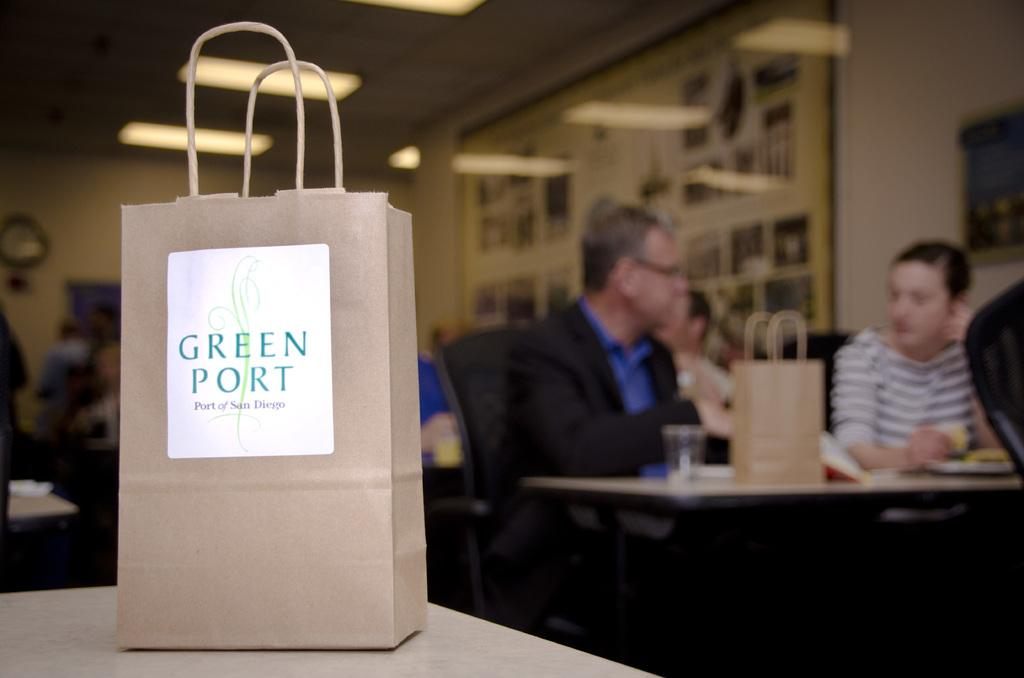What is on the table in the image? There is a paper bag on a table in the image. Can you describe the location of the paper bag? The paper bag is on a table in the image. What can be seen behind the paper bag? There are people visible behind the paper bag. How many tables are present in the image? There is at least one table present in the image. What else is on the table besides the paper bag? There are objects on the table. What type of produce is being harvested on the side of the table in the image? There is no produce or harvesting activity visible in the image; it only shows a paper bag on a table with people behind it. 